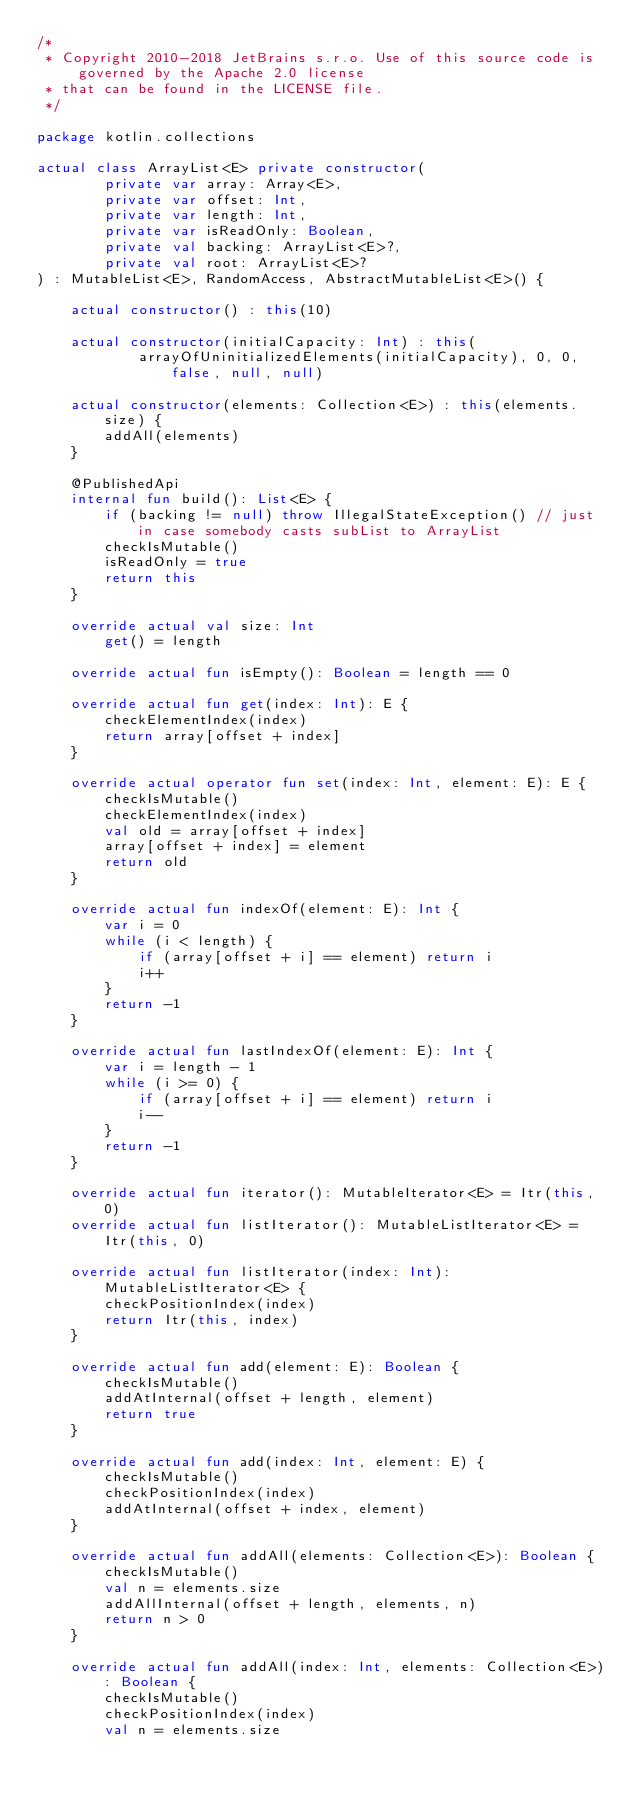Convert code to text. <code><loc_0><loc_0><loc_500><loc_500><_Kotlin_>/*
 * Copyright 2010-2018 JetBrains s.r.o. Use of this source code is governed by the Apache 2.0 license
 * that can be found in the LICENSE file.
 */

package kotlin.collections

actual class ArrayList<E> private constructor(
        private var array: Array<E>,
        private var offset: Int,
        private var length: Int,
        private var isReadOnly: Boolean,
        private val backing: ArrayList<E>?,
        private val root: ArrayList<E>?
) : MutableList<E>, RandomAccess, AbstractMutableList<E>() {

    actual constructor() : this(10)

    actual constructor(initialCapacity: Int) : this(
            arrayOfUninitializedElements(initialCapacity), 0, 0, false, null, null)

    actual constructor(elements: Collection<E>) : this(elements.size) {
        addAll(elements)
    }

    @PublishedApi
    internal fun build(): List<E> {
        if (backing != null) throw IllegalStateException() // just in case somebody casts subList to ArrayList
        checkIsMutable()
        isReadOnly = true
        return this
    }

    override actual val size: Int
        get() = length

    override actual fun isEmpty(): Boolean = length == 0

    override actual fun get(index: Int): E {
        checkElementIndex(index)
        return array[offset + index]
    }

    override actual operator fun set(index: Int, element: E): E {
        checkIsMutable()
        checkElementIndex(index)
        val old = array[offset + index]
        array[offset + index] = element
        return old
    }

    override actual fun indexOf(element: E): Int {
        var i = 0
        while (i < length) {
            if (array[offset + i] == element) return i
            i++
        }
        return -1
    }

    override actual fun lastIndexOf(element: E): Int {
        var i = length - 1
        while (i >= 0) {
            if (array[offset + i] == element) return i
            i--
        }
        return -1
    }

    override actual fun iterator(): MutableIterator<E> = Itr(this, 0)
    override actual fun listIterator(): MutableListIterator<E> = Itr(this, 0)

    override actual fun listIterator(index: Int): MutableListIterator<E> {
        checkPositionIndex(index)
        return Itr(this, index)
    }

    override actual fun add(element: E): Boolean {
        checkIsMutable()
        addAtInternal(offset + length, element)
        return true
    }

    override actual fun add(index: Int, element: E) {
        checkIsMutable()
        checkPositionIndex(index)
        addAtInternal(offset + index, element)
    }

    override actual fun addAll(elements: Collection<E>): Boolean {
        checkIsMutable()
        val n = elements.size
        addAllInternal(offset + length, elements, n)
        return n > 0
    }

    override actual fun addAll(index: Int, elements: Collection<E>): Boolean {
        checkIsMutable()
        checkPositionIndex(index)
        val n = elements.size</code> 